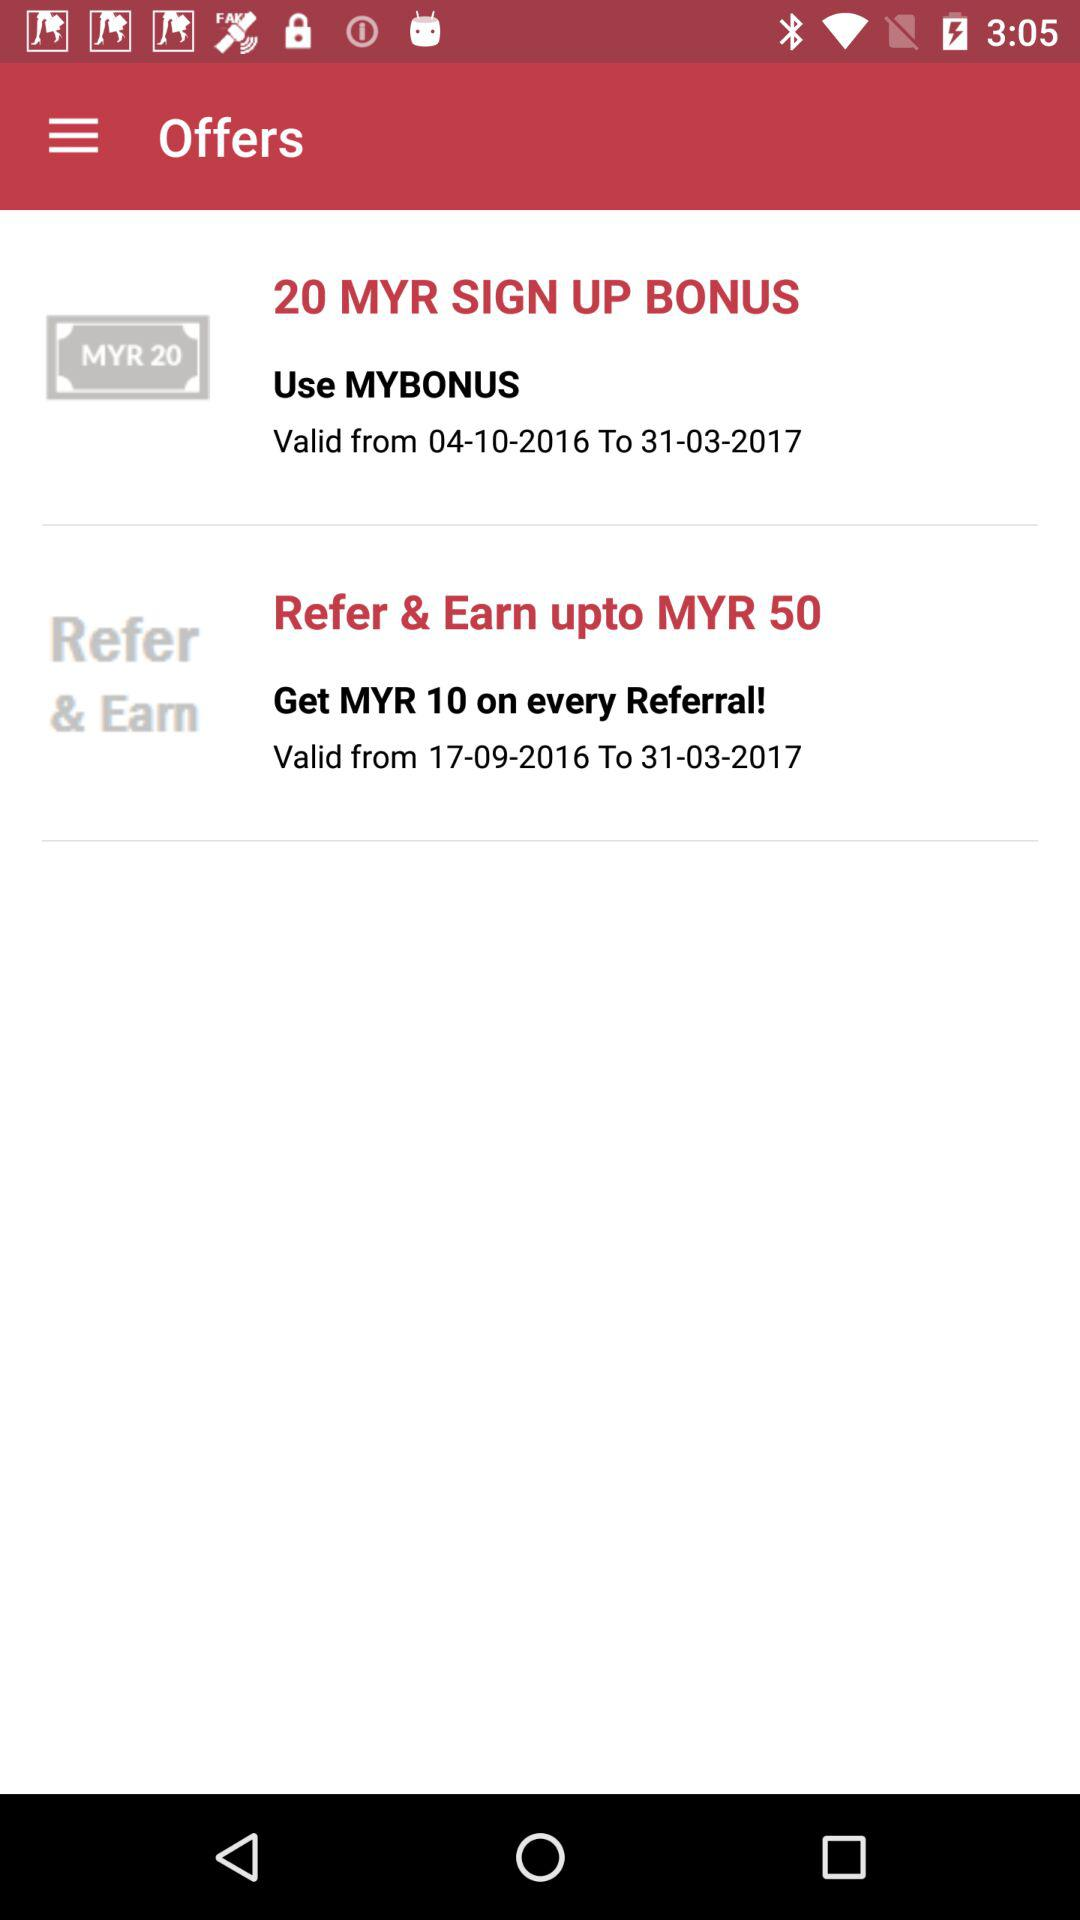How many MYR will we get on every referral? You will get MYR 10 for every referral. 